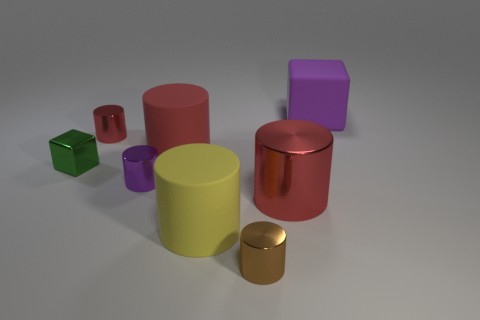Can you tell me which objects appear to have reflective surfaces? Certainly! The larger red and small gold cylinders, as well as the purple cube, display reflective qualities indicative of metallic materials. 